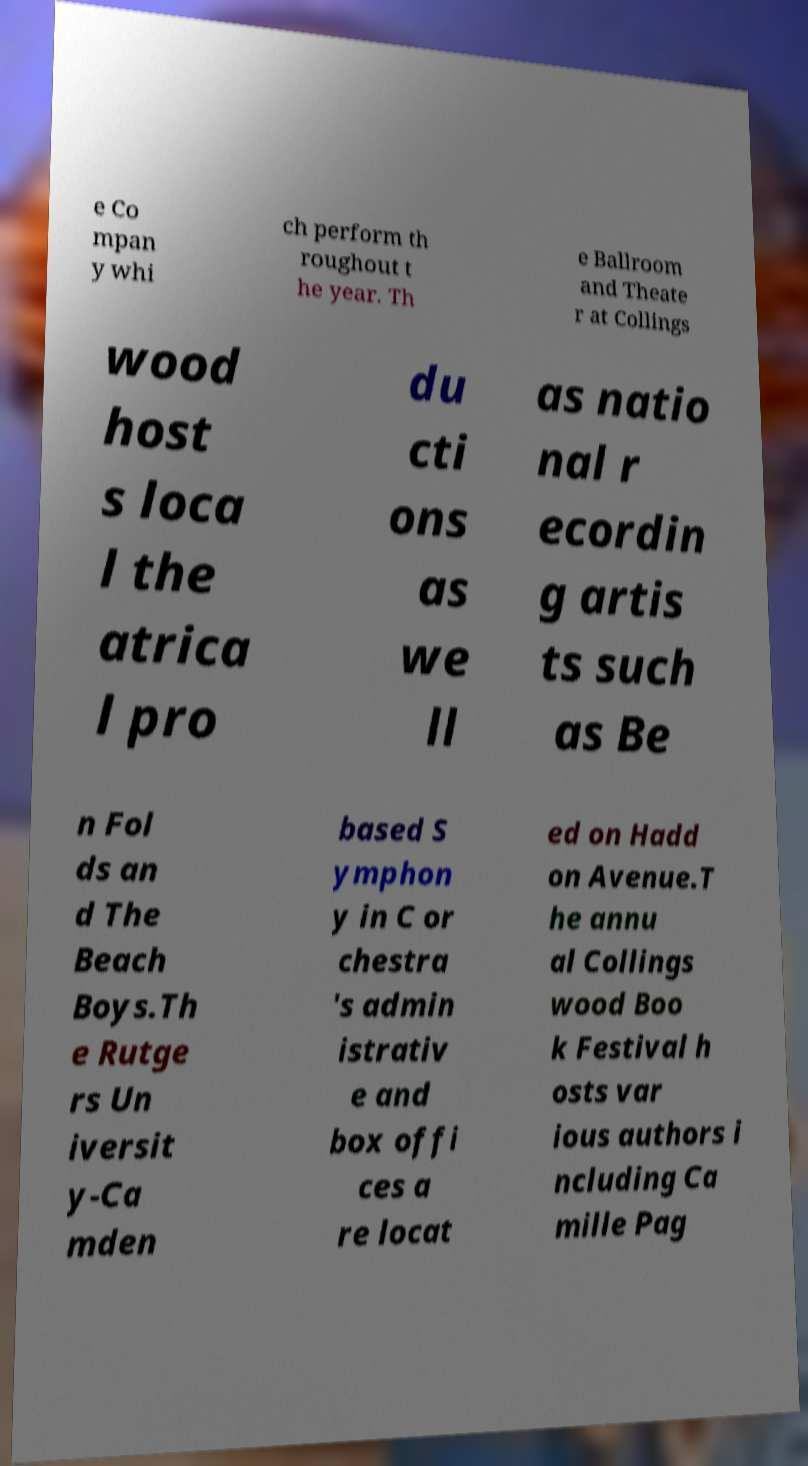Could you assist in decoding the text presented in this image and type it out clearly? e Co mpan y whi ch perform th roughout t he year. Th e Ballroom and Theate r at Collings wood host s loca l the atrica l pro du cti ons as we ll as natio nal r ecordin g artis ts such as Be n Fol ds an d The Beach Boys.Th e Rutge rs Un iversit y-Ca mden based S ymphon y in C or chestra 's admin istrativ e and box offi ces a re locat ed on Hadd on Avenue.T he annu al Collings wood Boo k Festival h osts var ious authors i ncluding Ca mille Pag 